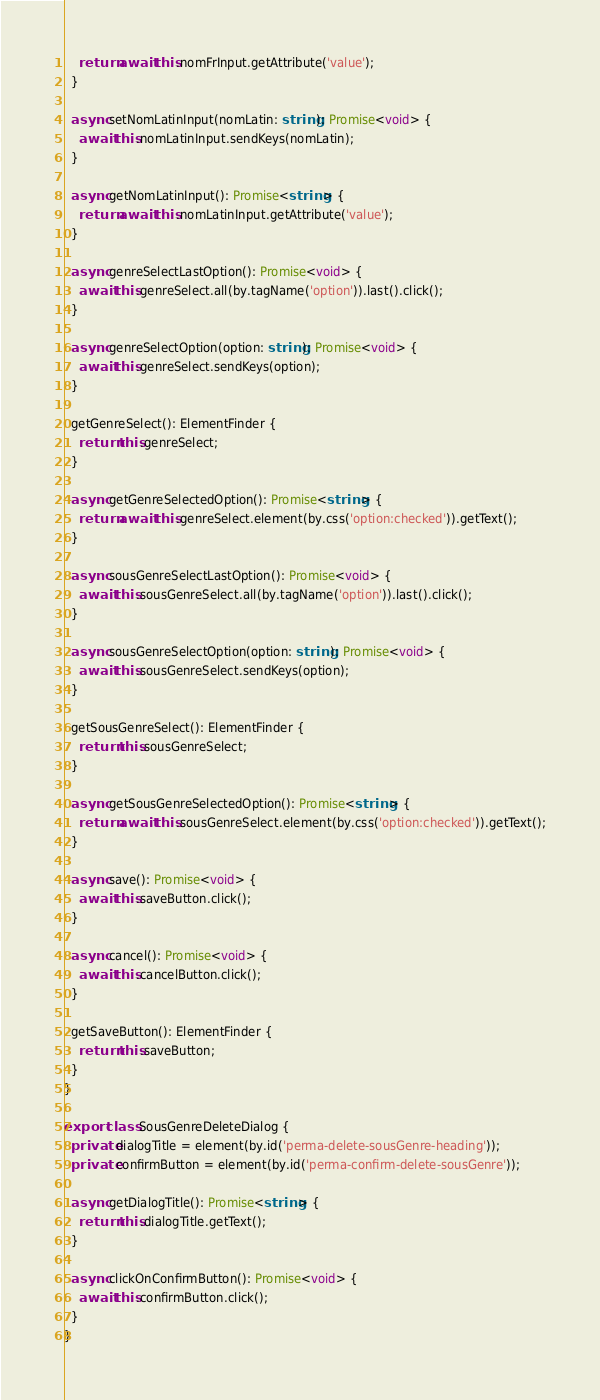<code> <loc_0><loc_0><loc_500><loc_500><_TypeScript_>    return await this.nomFrInput.getAttribute('value');
  }

  async setNomLatinInput(nomLatin: string): Promise<void> {
    await this.nomLatinInput.sendKeys(nomLatin);
  }

  async getNomLatinInput(): Promise<string> {
    return await this.nomLatinInput.getAttribute('value');
  }

  async genreSelectLastOption(): Promise<void> {
    await this.genreSelect.all(by.tagName('option')).last().click();
  }

  async genreSelectOption(option: string): Promise<void> {
    await this.genreSelect.sendKeys(option);
  }

  getGenreSelect(): ElementFinder {
    return this.genreSelect;
  }

  async getGenreSelectedOption(): Promise<string> {
    return await this.genreSelect.element(by.css('option:checked')).getText();
  }

  async sousGenreSelectLastOption(): Promise<void> {
    await this.sousGenreSelect.all(by.tagName('option')).last().click();
  }

  async sousGenreSelectOption(option: string): Promise<void> {
    await this.sousGenreSelect.sendKeys(option);
  }

  getSousGenreSelect(): ElementFinder {
    return this.sousGenreSelect;
  }

  async getSousGenreSelectedOption(): Promise<string> {
    return await this.sousGenreSelect.element(by.css('option:checked')).getText();
  }

  async save(): Promise<void> {
    await this.saveButton.click();
  }

  async cancel(): Promise<void> {
    await this.cancelButton.click();
  }

  getSaveButton(): ElementFinder {
    return this.saveButton;
  }
}

export class SousGenreDeleteDialog {
  private dialogTitle = element(by.id('perma-delete-sousGenre-heading'));
  private confirmButton = element(by.id('perma-confirm-delete-sousGenre'));

  async getDialogTitle(): Promise<string> {
    return this.dialogTitle.getText();
  }

  async clickOnConfirmButton(): Promise<void> {
    await this.confirmButton.click();
  }
}
</code> 